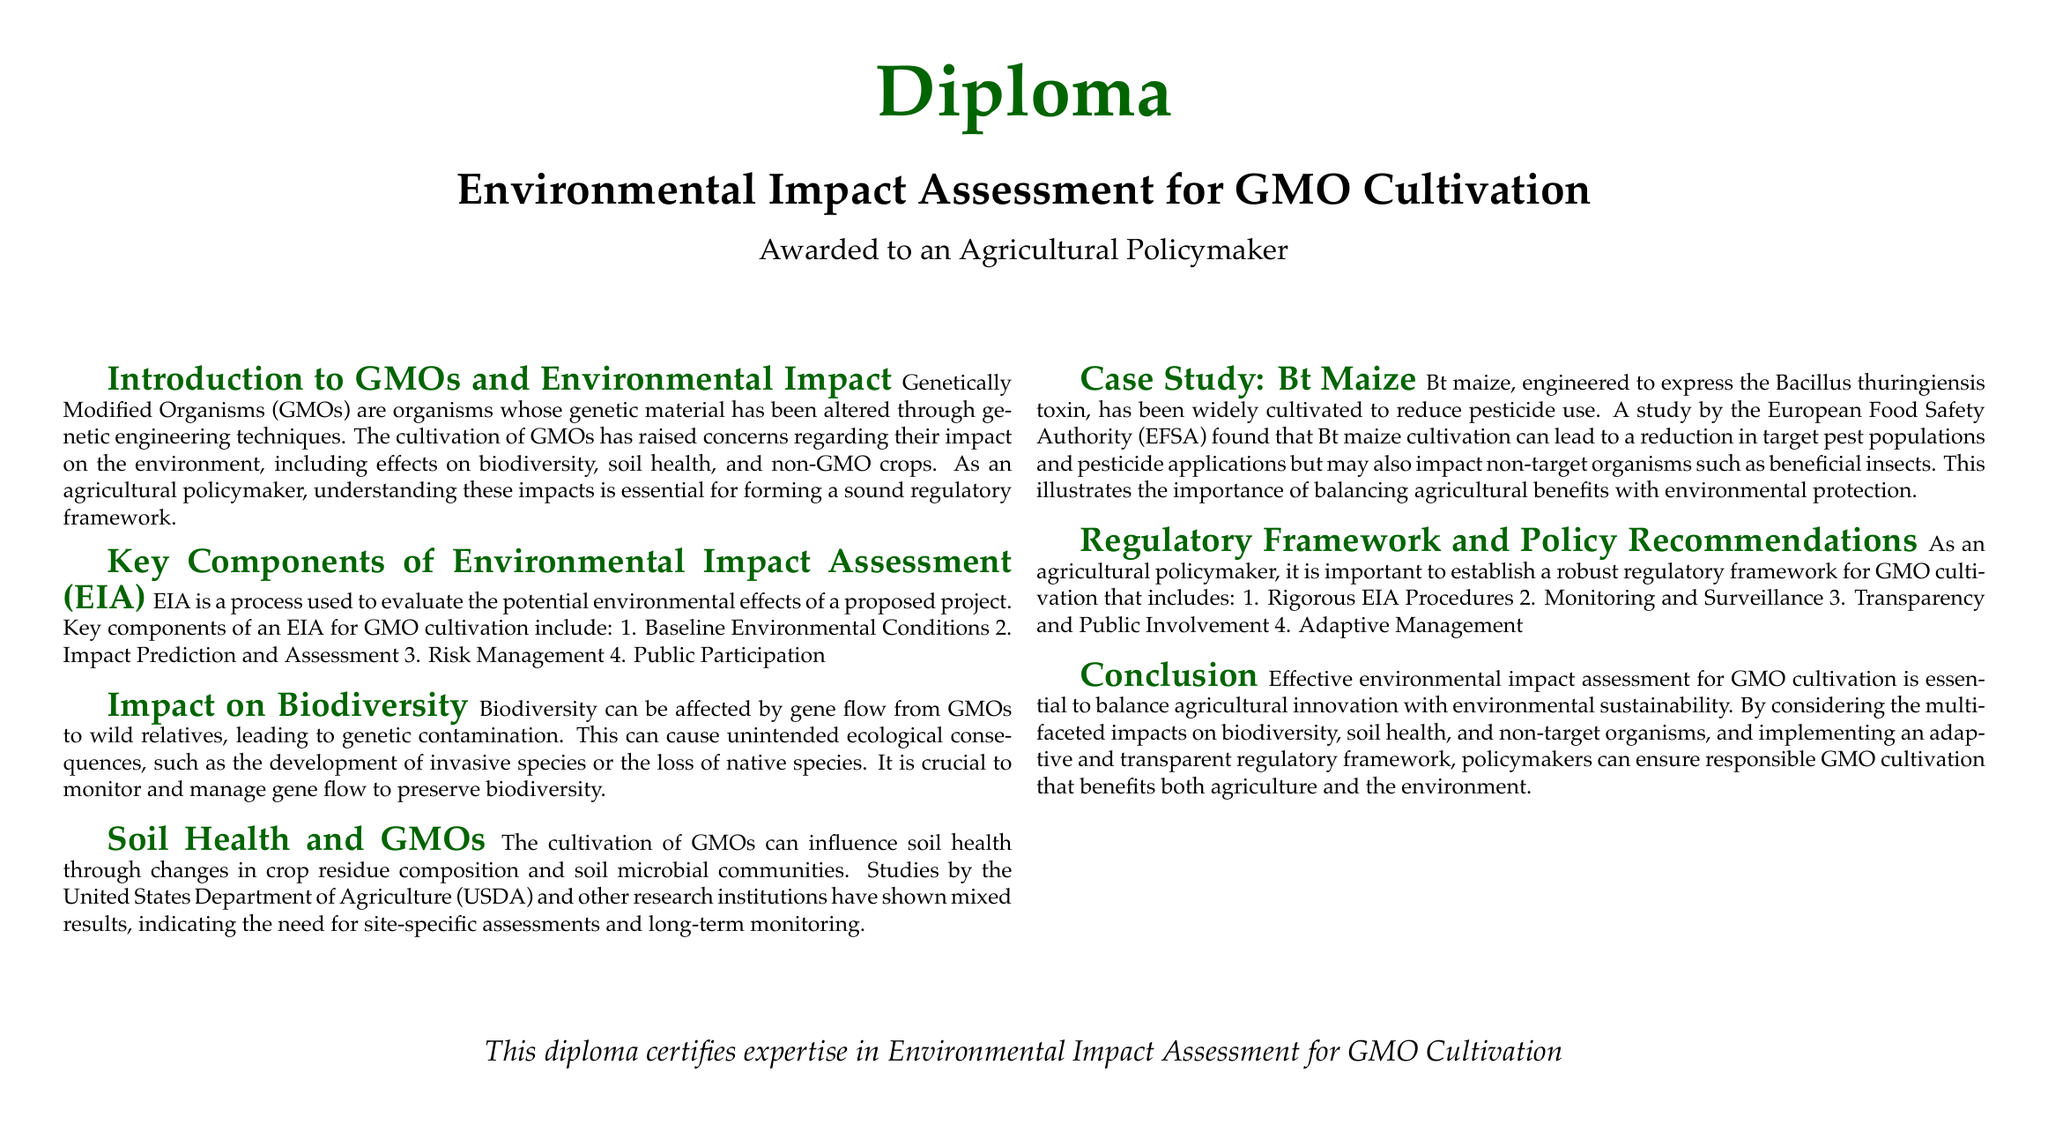what is the title of the diploma? The title of the diploma is explicitly stated at the beginning of the document.
Answer: Environmental Impact Assessment for GMO Cultivation who is the diploma awarded to? The document mentions the recipient of the diploma.
Answer: an Agricultural Policymaker what are the key components of EIA for GMO cultivation? The document lists specific components that are integral to the EIA process for GMO cultivation.
Answer: Baseline Environmental Conditions, Impact Prediction and Assessment, Risk Management, Public Participation what is one potential impact of GMOs on biodiversity? The document discusses a specific consequence of GMO cultivation related to biodiversity.
Answer: genetic contamination which crop is used as a case study in the document? The document includes a specific crop example to illustrate the environmental impact assessment.
Answer: Bt maize what does EIA stand for? The acronym is defined at the beginning of the section discussing its components.
Answer: Environmental Impact Assessment what is one policy recommendation mentioned for GMO cultivation? The document provides specific recommendations for the regulatory framework.
Answer: Rigorous EIA Procedures which organization's study is referenced regarding Bt maize? A prominent organization is cited in relation to the study of Bt maize.
Answer: European Food Safety Authority 